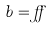<formula> <loc_0><loc_0><loc_500><loc_500>b = \alpha</formula> 